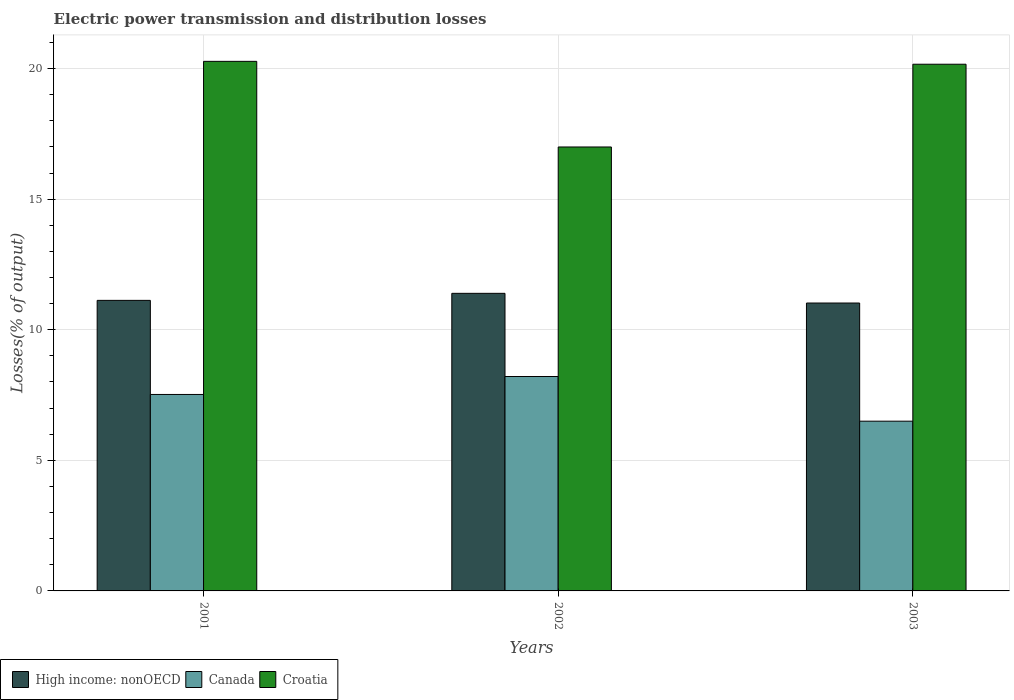How many different coloured bars are there?
Give a very brief answer. 3. Are the number of bars per tick equal to the number of legend labels?
Make the answer very short. Yes. How many bars are there on the 1st tick from the left?
Ensure brevity in your answer.  3. How many bars are there on the 2nd tick from the right?
Ensure brevity in your answer.  3. What is the label of the 1st group of bars from the left?
Provide a short and direct response. 2001. In how many cases, is the number of bars for a given year not equal to the number of legend labels?
Keep it short and to the point. 0. What is the electric power transmission and distribution losses in Croatia in 2002?
Ensure brevity in your answer.  17. Across all years, what is the maximum electric power transmission and distribution losses in Canada?
Ensure brevity in your answer.  8.21. Across all years, what is the minimum electric power transmission and distribution losses in High income: nonOECD?
Provide a short and direct response. 11.02. In which year was the electric power transmission and distribution losses in High income: nonOECD maximum?
Keep it short and to the point. 2002. What is the total electric power transmission and distribution losses in Croatia in the graph?
Offer a very short reply. 57.44. What is the difference between the electric power transmission and distribution losses in Canada in 2001 and that in 2003?
Your answer should be compact. 1.02. What is the difference between the electric power transmission and distribution losses in High income: nonOECD in 2003 and the electric power transmission and distribution losses in Croatia in 2002?
Keep it short and to the point. -5.97. What is the average electric power transmission and distribution losses in Canada per year?
Give a very brief answer. 7.41. In the year 2001, what is the difference between the electric power transmission and distribution losses in Croatia and electric power transmission and distribution losses in Canada?
Give a very brief answer. 12.75. In how many years, is the electric power transmission and distribution losses in Croatia greater than 8 %?
Offer a terse response. 3. What is the ratio of the electric power transmission and distribution losses in High income: nonOECD in 2001 to that in 2002?
Provide a succinct answer. 0.98. Is the difference between the electric power transmission and distribution losses in Croatia in 2002 and 2003 greater than the difference between the electric power transmission and distribution losses in Canada in 2002 and 2003?
Provide a short and direct response. No. What is the difference between the highest and the second highest electric power transmission and distribution losses in Croatia?
Provide a short and direct response. 0.11. What is the difference between the highest and the lowest electric power transmission and distribution losses in Canada?
Your answer should be compact. 1.71. In how many years, is the electric power transmission and distribution losses in Croatia greater than the average electric power transmission and distribution losses in Croatia taken over all years?
Your answer should be very brief. 2. What does the 3rd bar from the left in 2003 represents?
Provide a succinct answer. Croatia. Is it the case that in every year, the sum of the electric power transmission and distribution losses in Canada and electric power transmission and distribution losses in Croatia is greater than the electric power transmission and distribution losses in High income: nonOECD?
Provide a short and direct response. Yes. Are all the bars in the graph horizontal?
Your response must be concise. No. How many years are there in the graph?
Ensure brevity in your answer.  3. Does the graph contain any zero values?
Your answer should be compact. No. Does the graph contain grids?
Your answer should be compact. Yes. How many legend labels are there?
Offer a very short reply. 3. How are the legend labels stacked?
Give a very brief answer. Horizontal. What is the title of the graph?
Your answer should be very brief. Electric power transmission and distribution losses. What is the label or title of the X-axis?
Your response must be concise. Years. What is the label or title of the Y-axis?
Provide a short and direct response. Losses(% of output). What is the Losses(% of output) of High income: nonOECD in 2001?
Ensure brevity in your answer.  11.13. What is the Losses(% of output) in Canada in 2001?
Provide a succinct answer. 7.52. What is the Losses(% of output) of Croatia in 2001?
Your response must be concise. 20.28. What is the Losses(% of output) of High income: nonOECD in 2002?
Make the answer very short. 11.39. What is the Losses(% of output) of Canada in 2002?
Your answer should be very brief. 8.21. What is the Losses(% of output) of Croatia in 2002?
Your answer should be very brief. 17. What is the Losses(% of output) of High income: nonOECD in 2003?
Offer a very short reply. 11.02. What is the Losses(% of output) in Canada in 2003?
Offer a terse response. 6.5. What is the Losses(% of output) in Croatia in 2003?
Provide a short and direct response. 20.17. Across all years, what is the maximum Losses(% of output) of High income: nonOECD?
Provide a short and direct response. 11.39. Across all years, what is the maximum Losses(% of output) in Canada?
Make the answer very short. 8.21. Across all years, what is the maximum Losses(% of output) in Croatia?
Offer a very short reply. 20.28. Across all years, what is the minimum Losses(% of output) of High income: nonOECD?
Provide a short and direct response. 11.02. Across all years, what is the minimum Losses(% of output) of Canada?
Your answer should be very brief. 6.5. Across all years, what is the minimum Losses(% of output) in Croatia?
Provide a short and direct response. 17. What is the total Losses(% of output) of High income: nonOECD in the graph?
Offer a terse response. 33.54. What is the total Losses(% of output) of Canada in the graph?
Provide a short and direct response. 22.23. What is the total Losses(% of output) in Croatia in the graph?
Give a very brief answer. 57.44. What is the difference between the Losses(% of output) of High income: nonOECD in 2001 and that in 2002?
Offer a very short reply. -0.27. What is the difference between the Losses(% of output) in Canada in 2001 and that in 2002?
Offer a very short reply. -0.69. What is the difference between the Losses(% of output) of Croatia in 2001 and that in 2002?
Provide a succinct answer. 3.28. What is the difference between the Losses(% of output) of High income: nonOECD in 2001 and that in 2003?
Your answer should be compact. 0.1. What is the difference between the Losses(% of output) of Canada in 2001 and that in 2003?
Offer a very short reply. 1.02. What is the difference between the Losses(% of output) of Croatia in 2001 and that in 2003?
Ensure brevity in your answer.  0.11. What is the difference between the Losses(% of output) in High income: nonOECD in 2002 and that in 2003?
Your answer should be very brief. 0.37. What is the difference between the Losses(% of output) of Canada in 2002 and that in 2003?
Your answer should be compact. 1.71. What is the difference between the Losses(% of output) of Croatia in 2002 and that in 2003?
Ensure brevity in your answer.  -3.17. What is the difference between the Losses(% of output) in High income: nonOECD in 2001 and the Losses(% of output) in Canada in 2002?
Make the answer very short. 2.92. What is the difference between the Losses(% of output) in High income: nonOECD in 2001 and the Losses(% of output) in Croatia in 2002?
Your answer should be very brief. -5.87. What is the difference between the Losses(% of output) of Canada in 2001 and the Losses(% of output) of Croatia in 2002?
Offer a terse response. -9.48. What is the difference between the Losses(% of output) of High income: nonOECD in 2001 and the Losses(% of output) of Canada in 2003?
Provide a succinct answer. 4.63. What is the difference between the Losses(% of output) in High income: nonOECD in 2001 and the Losses(% of output) in Croatia in 2003?
Give a very brief answer. -9.04. What is the difference between the Losses(% of output) in Canada in 2001 and the Losses(% of output) in Croatia in 2003?
Your answer should be compact. -12.64. What is the difference between the Losses(% of output) in High income: nonOECD in 2002 and the Losses(% of output) in Canada in 2003?
Your response must be concise. 4.9. What is the difference between the Losses(% of output) in High income: nonOECD in 2002 and the Losses(% of output) in Croatia in 2003?
Your answer should be very brief. -8.77. What is the difference between the Losses(% of output) in Canada in 2002 and the Losses(% of output) in Croatia in 2003?
Your answer should be compact. -11.96. What is the average Losses(% of output) of High income: nonOECD per year?
Make the answer very short. 11.18. What is the average Losses(% of output) in Canada per year?
Offer a very short reply. 7.41. What is the average Losses(% of output) of Croatia per year?
Offer a terse response. 19.15. In the year 2001, what is the difference between the Losses(% of output) in High income: nonOECD and Losses(% of output) in Canada?
Your response must be concise. 3.6. In the year 2001, what is the difference between the Losses(% of output) of High income: nonOECD and Losses(% of output) of Croatia?
Make the answer very short. -9.15. In the year 2001, what is the difference between the Losses(% of output) in Canada and Losses(% of output) in Croatia?
Provide a succinct answer. -12.75. In the year 2002, what is the difference between the Losses(% of output) in High income: nonOECD and Losses(% of output) in Canada?
Your response must be concise. 3.18. In the year 2002, what is the difference between the Losses(% of output) of High income: nonOECD and Losses(% of output) of Croatia?
Give a very brief answer. -5.6. In the year 2002, what is the difference between the Losses(% of output) of Canada and Losses(% of output) of Croatia?
Ensure brevity in your answer.  -8.79. In the year 2003, what is the difference between the Losses(% of output) of High income: nonOECD and Losses(% of output) of Canada?
Keep it short and to the point. 4.52. In the year 2003, what is the difference between the Losses(% of output) in High income: nonOECD and Losses(% of output) in Croatia?
Make the answer very short. -9.14. In the year 2003, what is the difference between the Losses(% of output) of Canada and Losses(% of output) of Croatia?
Keep it short and to the point. -13.67. What is the ratio of the Losses(% of output) of High income: nonOECD in 2001 to that in 2002?
Provide a short and direct response. 0.98. What is the ratio of the Losses(% of output) of Canada in 2001 to that in 2002?
Offer a terse response. 0.92. What is the ratio of the Losses(% of output) in Croatia in 2001 to that in 2002?
Offer a terse response. 1.19. What is the ratio of the Losses(% of output) of High income: nonOECD in 2001 to that in 2003?
Your answer should be very brief. 1.01. What is the ratio of the Losses(% of output) in Canada in 2001 to that in 2003?
Give a very brief answer. 1.16. What is the ratio of the Losses(% of output) of Croatia in 2001 to that in 2003?
Provide a short and direct response. 1.01. What is the ratio of the Losses(% of output) of High income: nonOECD in 2002 to that in 2003?
Your answer should be very brief. 1.03. What is the ratio of the Losses(% of output) of Canada in 2002 to that in 2003?
Provide a short and direct response. 1.26. What is the ratio of the Losses(% of output) of Croatia in 2002 to that in 2003?
Provide a short and direct response. 0.84. What is the difference between the highest and the second highest Losses(% of output) of High income: nonOECD?
Make the answer very short. 0.27. What is the difference between the highest and the second highest Losses(% of output) in Canada?
Provide a short and direct response. 0.69. What is the difference between the highest and the second highest Losses(% of output) of Croatia?
Your answer should be very brief. 0.11. What is the difference between the highest and the lowest Losses(% of output) of High income: nonOECD?
Your answer should be compact. 0.37. What is the difference between the highest and the lowest Losses(% of output) of Canada?
Give a very brief answer. 1.71. What is the difference between the highest and the lowest Losses(% of output) of Croatia?
Ensure brevity in your answer.  3.28. 